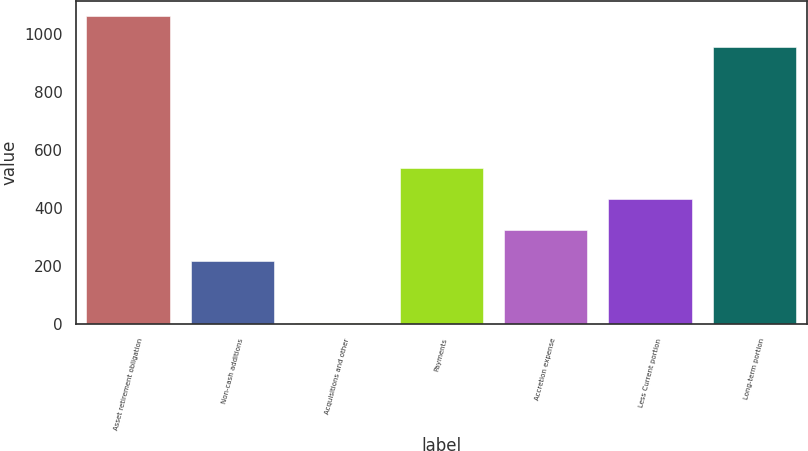<chart> <loc_0><loc_0><loc_500><loc_500><bar_chart><fcel>Asset retirement obligation<fcel>Non-cash additions<fcel>Acquisitions and other<fcel>Payments<fcel>Accretion expense<fcel>Less Current portion<fcel>Long-term portion<nl><fcel>1059.75<fcel>217.3<fcel>3<fcel>538.75<fcel>324.45<fcel>431.6<fcel>952.6<nl></chart> 